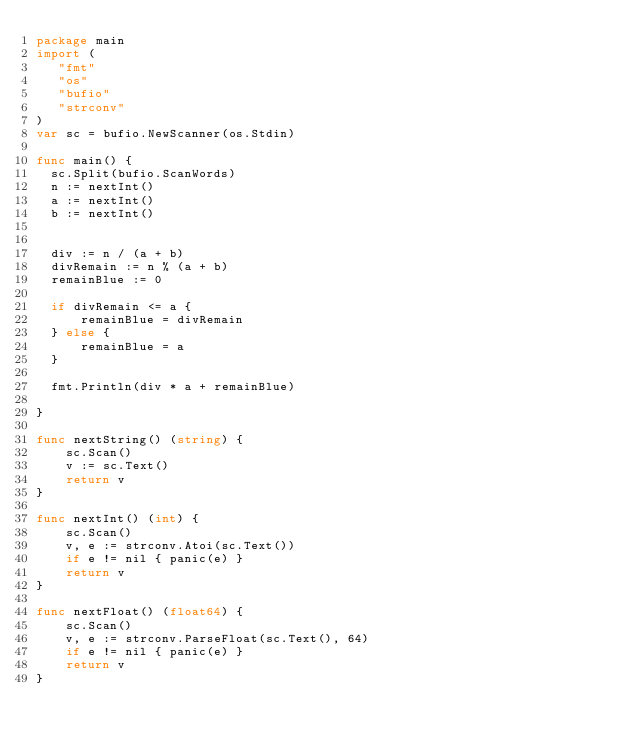Convert code to text. <code><loc_0><loc_0><loc_500><loc_500><_Go_>package main
import (
   "fmt"
   "os"
   "bufio"
   "strconv"
)
var sc = bufio.NewScanner(os.Stdin)

func main() {
  sc.Split(bufio.ScanWords)
  n := nextInt()
  a := nextInt()
  b := nextInt()


  div := n / (a + b)
  divRemain := n % (a + b)
  remainBlue := 0

  if divRemain <= a {
	  remainBlue = divRemain
  } else {
	  remainBlue = a
  }

  fmt.Println(div * a + remainBlue)

}

func nextString() (string) {
	sc.Scan()
	v := sc.Text()
	return v
}

func nextInt() (int) {
	sc.Scan()
	v, e := strconv.Atoi(sc.Text())
    if e != nil { panic(e) }
    return v
}

func nextFloat() (float64) {
	sc.Scan()
	v, e := strconv.ParseFloat(sc.Text(), 64)
    if e != nil { panic(e) }
    return v
}
</code> 